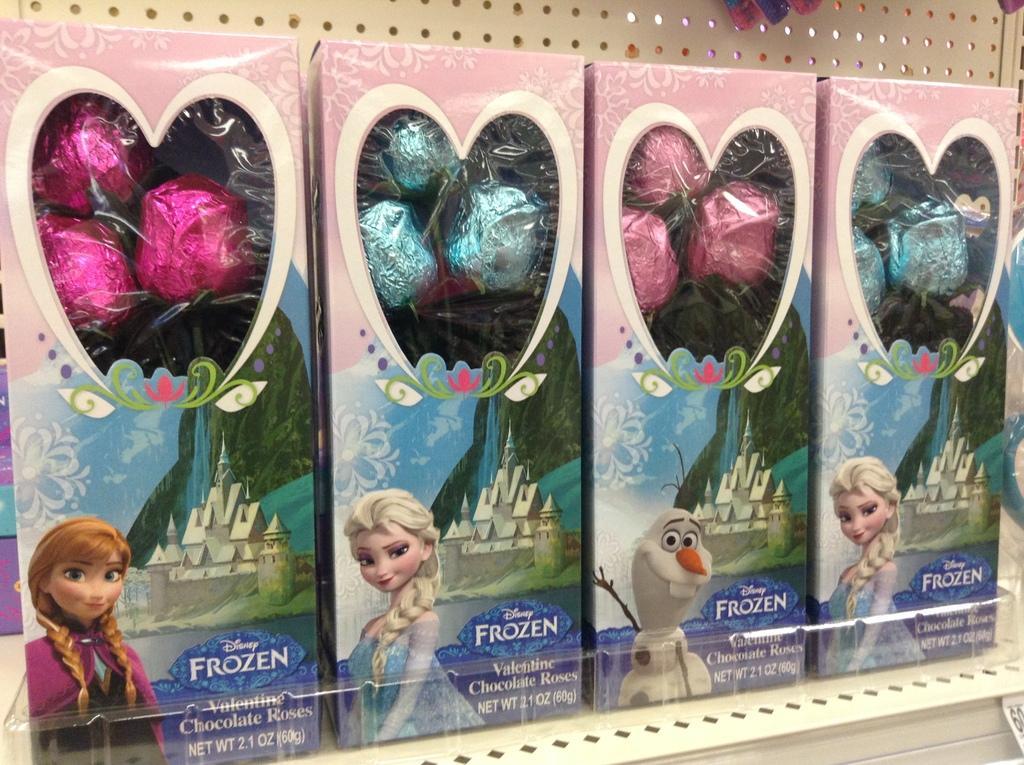Can you describe this image briefly? This image consists of chocolate boxes are kept in a rack. The rack is in white color. There are four boxes. 